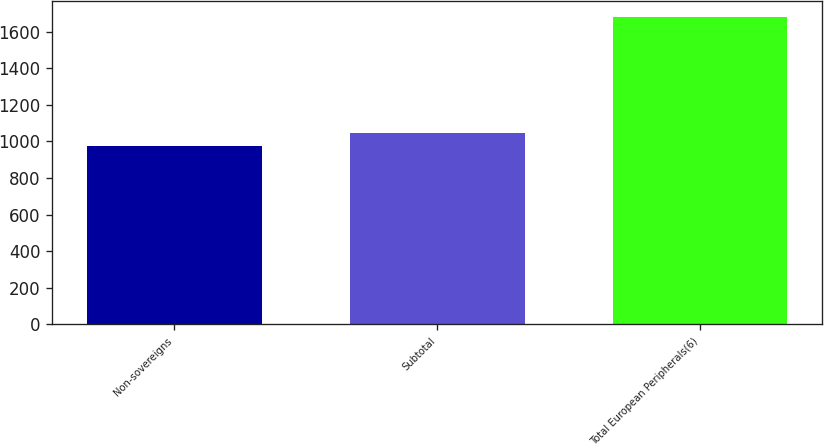<chart> <loc_0><loc_0><loc_500><loc_500><bar_chart><fcel>Non-sovereigns<fcel>Subtotal<fcel>Total European Peripherals(6)<nl><fcel>976<fcel>1046.6<fcel>1682<nl></chart> 